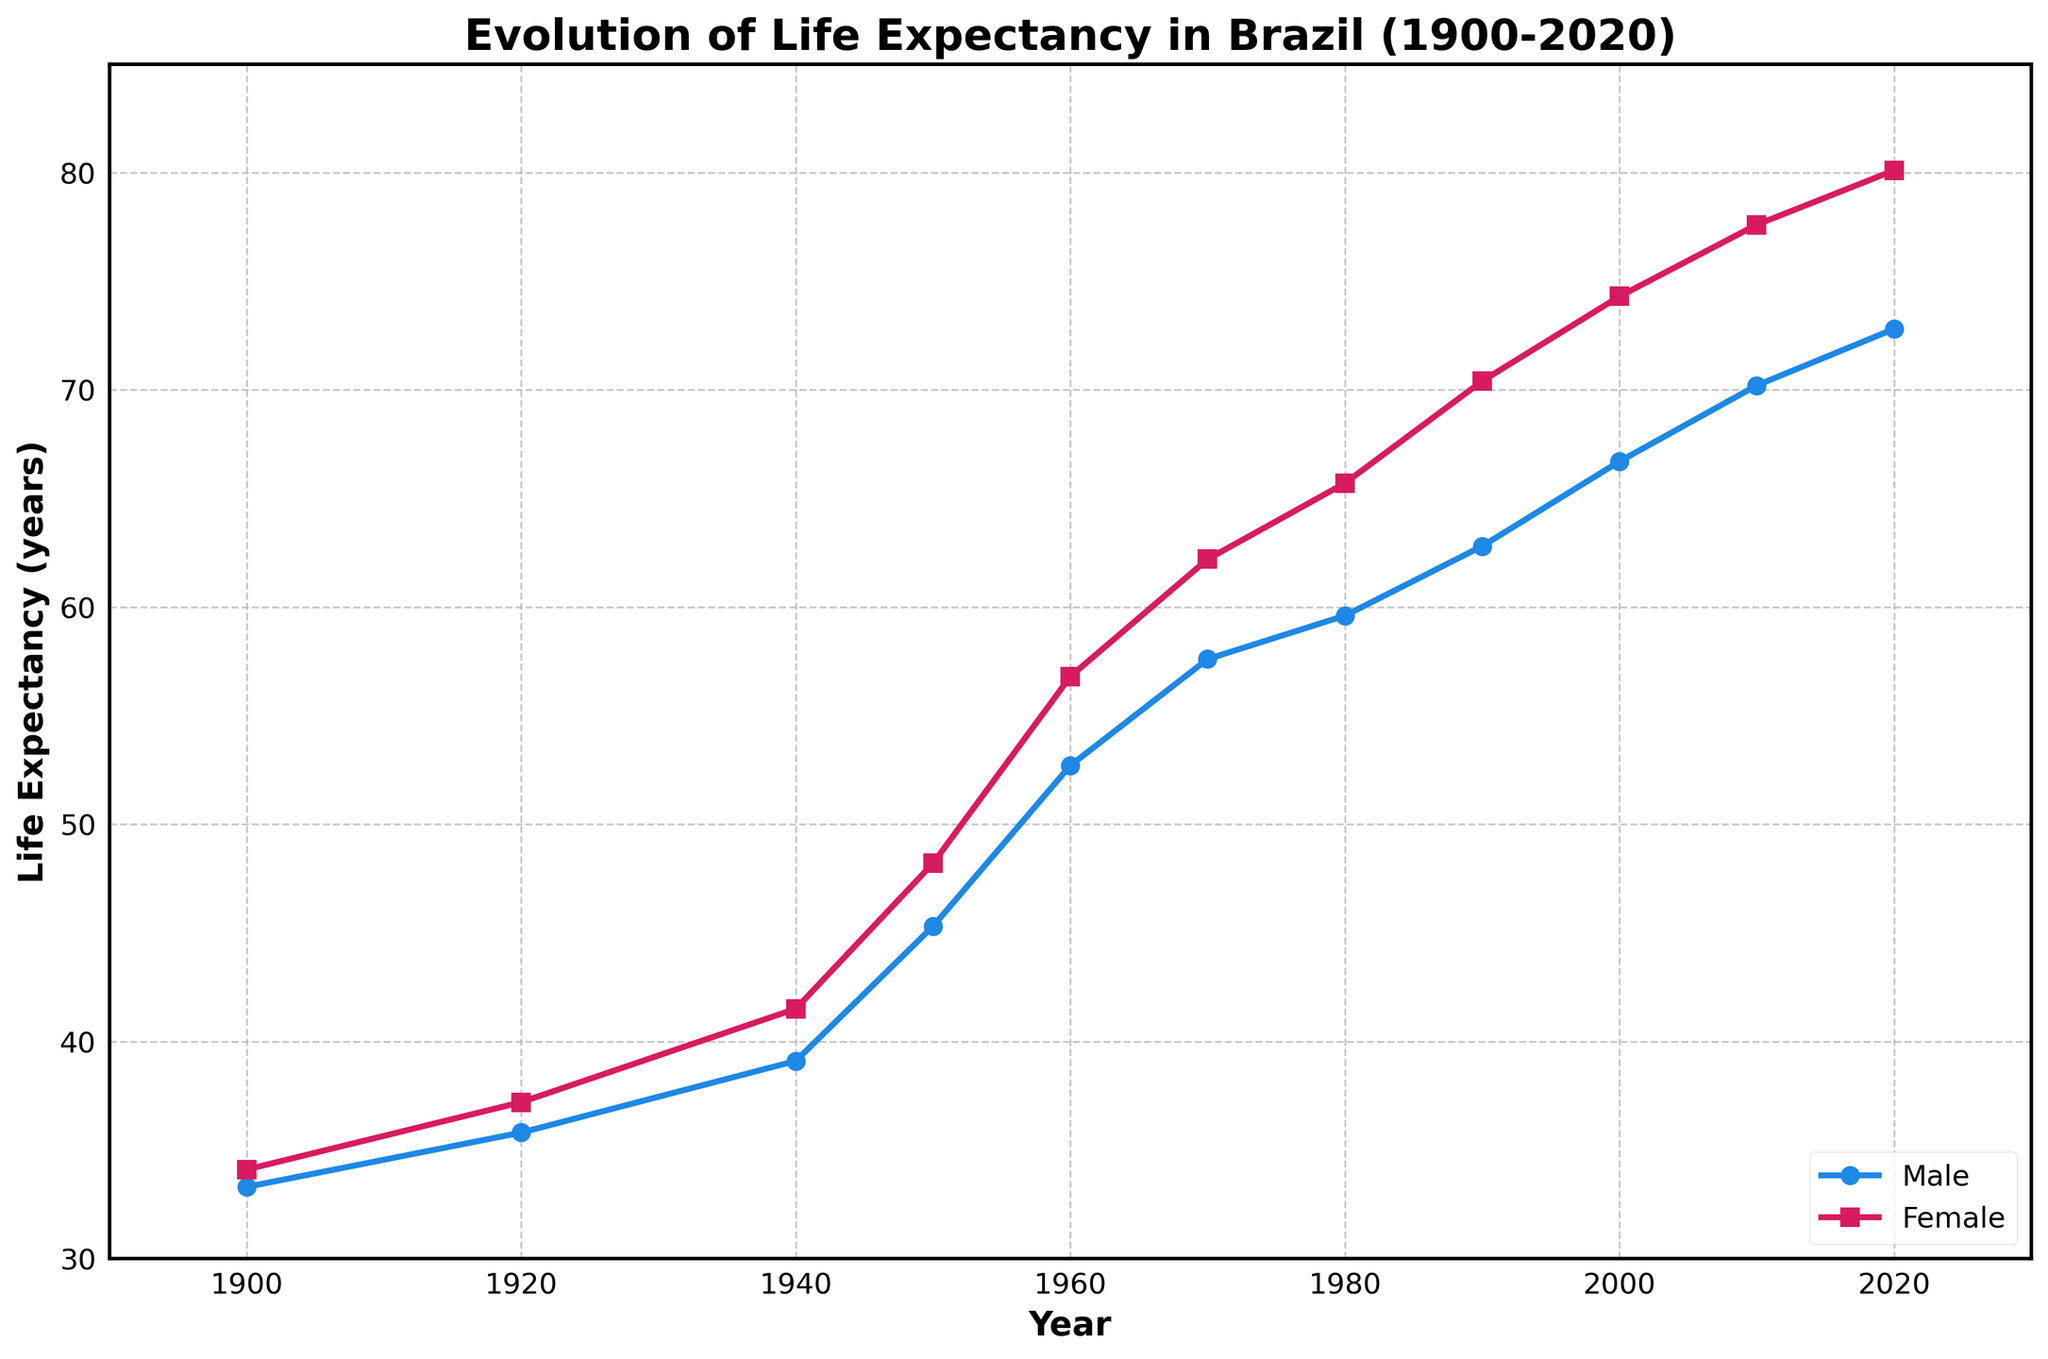What is the difference in life expectancy between males and females in 1950? To determine the difference in life expectancy, we need to subtract the male life expectancy from the female life expectancy for the year 1950. The values are 48.2 years for females and 45.3 years for males, therefore 48.2 - 45.3 = 2.9 years.
Answer: 2.9 years In which year did males have a life expectancy of 70.2 years? By observing the plot, the point where the male life expectancy line reaches 70.2 years corresponds to the year 2010.
Answer: 2010 What is the average life expectancy for females in 1920 and 1960? To find the average, sum the female life expectancy values for the years 1920 and 1960, then divide by 2. (37.2 + 56.8) / 2 = 47.0 years.
Answer: 47.0 years Which gender saw a greater increase in life expectancy between 1980 and 2020? The increase in life expectancy for males from 1980 to 2020 can be calculated as 72.8 - 59.6 = 13.2 years. For females, it is 80.1 - 65.7 = 14.4 years. Comparing these, females had a greater increase.
Answer: Females Is there any year where male and female life expectancies are equal? By examining the plot, no year shows male and female life expectancies being equal, as the female life expectancy is always higher.
Answer: No How much higher was the female life expectancy compared to the male in 1990? To find out how much higher, subtract the male life expectancy from the female life expectancy for the year 1990. The values are 70.4 years for females and 62.8 years for males, therefore 70.4 - 62.8 = 7.6 years.
Answer: 7.6 years What trend do you observe in life expectancy from 1900 to 2020? Over the period from 1900 to 2020, the general trend for both males and females is an increase in life expectancy. Both genders show steady progress, with females consistently having higher life expectancy than males.
Answer: Increasing What is the visual difference between the lines representing male and female life expectancies? The male life expectancy line is represented using blue circles while the female life expectancy line uses red squares, making them visually distinguishable.
Answer: Color and marker type By how many years did male life expectancy increase from 1970 to 2000? Calculate the increase by subtracting the male life expectancy in 1970 from that in 2000. The values are 66.7 years in 2000 and 57.6 years in 1970, thus 66.7 - 57.6 = 9.1 years.
Answer: 9.1 years 